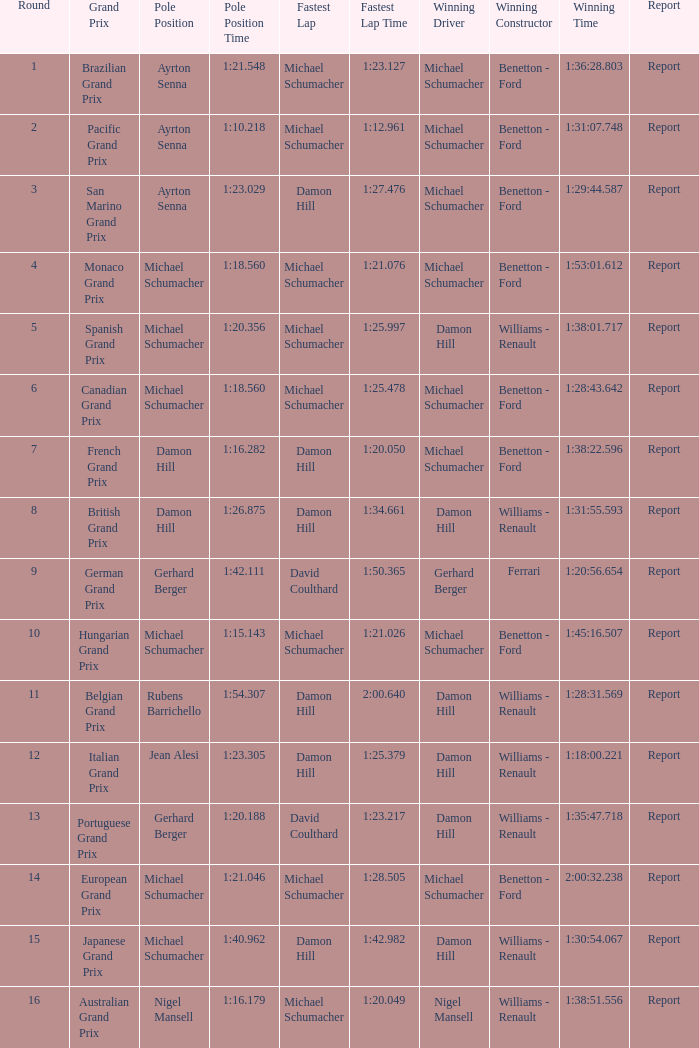Name the pole position at the japanese grand prix when the fastest lap is damon hill Michael Schumacher. 